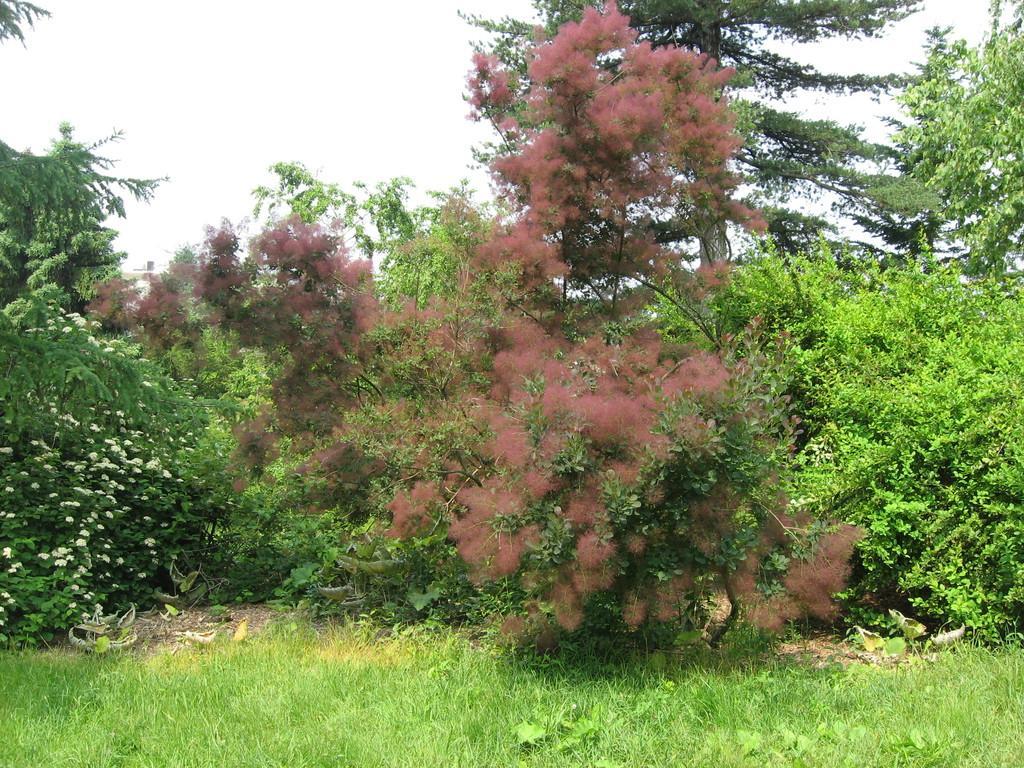Describe this image in one or two sentences. On the ground there is grass. In the background there are trees and sky. 